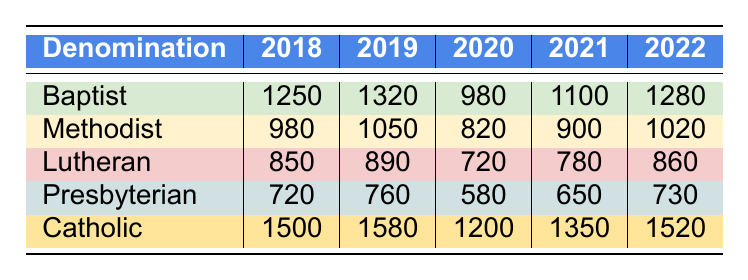What was the attendance of the Catholic youth Bible study group in 2020? The attendance for the Catholic group in 2020 is directly given in the table as 1200.
Answer: 1200 Which denomination had the highest attendance in 2019? By comparing the attendance values for all denominations in 2019, the Catholic group had the highest number at 1580.
Answer: Catholic What was the average attendance of the Baptist group over the years 2018 to 2022? To find the average, sum the attendance records for the Baptist group: 1250 + 1320 + 980 + 1100 + 1280 = 4930. Divide by the number of years (5): 4930 / 5 = 986.
Answer: 986 How many total attendees were recorded for the Presbyterian group from 2018 to 2022? Sum the attendance records for the Presbyterian group: 720 + 760 + 580 + 650 + 730 = 3440.
Answer: 3440 Did the attendance for the Methodist group decline in 2020 compared to 2019? The attendance in 2019 was 1050, and in 2020 it was 820. Since 820 is less than 1050, attendance did decline.
Answer: Yes Which year saw the lowest overall attendance for the Lutheran denomination? Checking the attendance figures for the Lutheran group, the lowest value is 720 in the year 2020.
Answer: 2020 What is the difference in attendance between the Catholic and Presbyterian groups in 2022? The attendance for the Catholic group in 2022 is 1520, while for the Presbyterian group it is 730. The difference is 1520 - 730 = 790.
Answer: 790 How many more attendees did the Baptist group have in 2018 compared to the Lutheran group in the same year? The Baptist attendance in 2018 was 1250 and the Lutheran attendance was 850. The difference is 1250 - 850 = 400.
Answer: 400 What was the trend of the Lutheran group's attendance from 2018 to 2022? The attendance numbers are 850, 890, 720, 780, and 860 respectively. This shows an initial increase, a decrease in 2020, a slight recovery in 2021, and an increase again in 2022. Overall, the trend is fluctuating but ends higher than 2018.
Answer: Fluctuating upward Which group had the most stable attendance over the years? Assessing the data, the Presbyterian group shows the least variability in attendance, ranging from 580 to 730, indicating the most stable attendance.
Answer: Presbyterian 